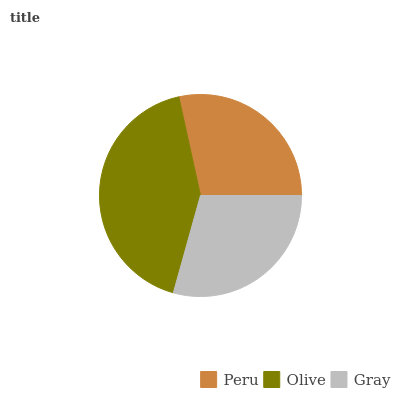Is Peru the minimum?
Answer yes or no. Yes. Is Olive the maximum?
Answer yes or no. Yes. Is Gray the minimum?
Answer yes or no. No. Is Gray the maximum?
Answer yes or no. No. Is Olive greater than Gray?
Answer yes or no. Yes. Is Gray less than Olive?
Answer yes or no. Yes. Is Gray greater than Olive?
Answer yes or no. No. Is Olive less than Gray?
Answer yes or no. No. Is Gray the high median?
Answer yes or no. Yes. Is Gray the low median?
Answer yes or no. Yes. Is Olive the high median?
Answer yes or no. No. Is Olive the low median?
Answer yes or no. No. 